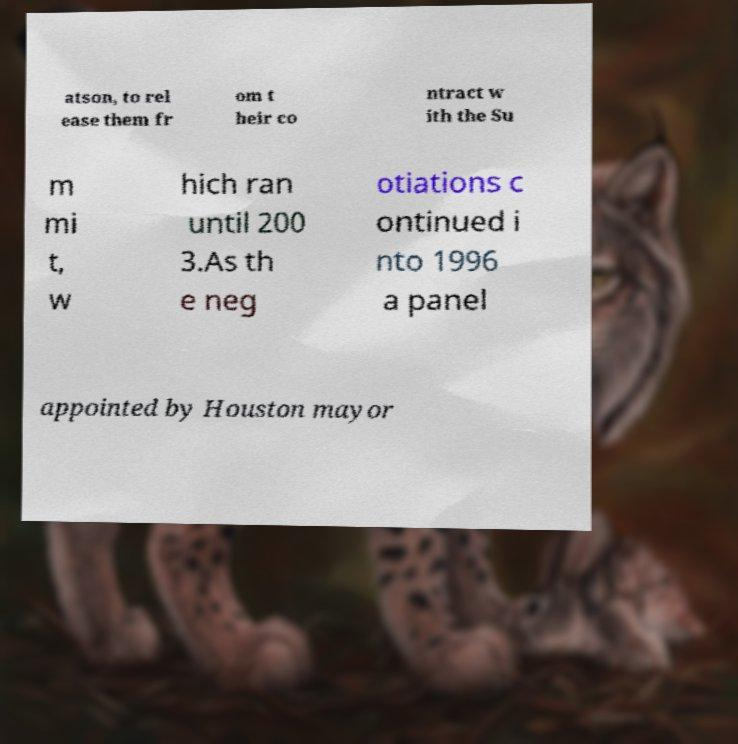Can you read and provide the text displayed in the image?This photo seems to have some interesting text. Can you extract and type it out for me? atson, to rel ease them fr om t heir co ntract w ith the Su m mi t, w hich ran until 200 3.As th e neg otiations c ontinued i nto 1996 a panel appointed by Houston mayor 